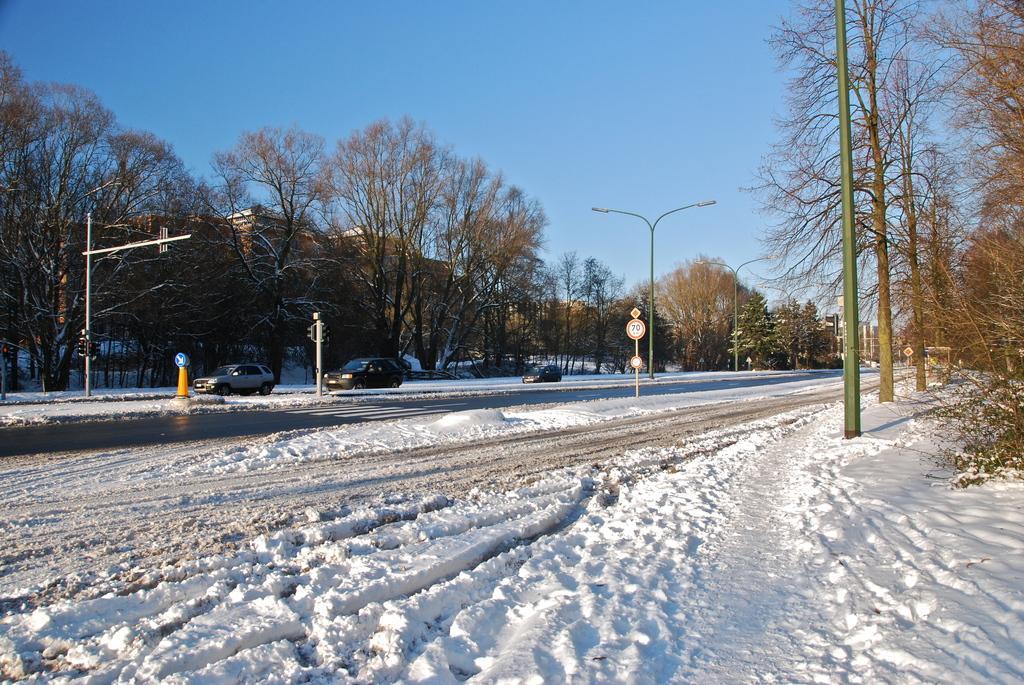Can you describe this image briefly? In this image, we can see vehicles, poles, traffic cones, trees and at the bottom, there is road covered with snow. At the top, there is sky. 